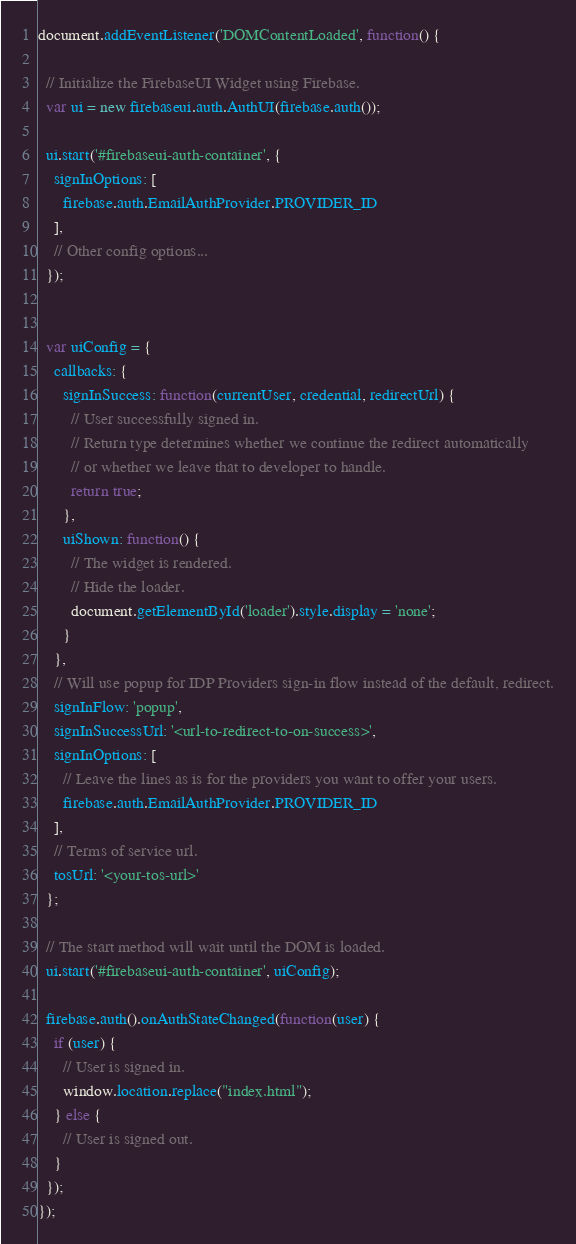Convert code to text. <code><loc_0><loc_0><loc_500><loc_500><_JavaScript_>document.addEventListener('DOMContentLoaded', function() {

  // Initialize the FirebaseUI Widget using Firebase.
  var ui = new firebaseui.auth.AuthUI(firebase.auth());

  ui.start('#firebaseui-auth-container', {
    signInOptions: [
      firebase.auth.EmailAuthProvider.PROVIDER_ID
    ],
    // Other config options...
  });


  var uiConfig = {
    callbacks: {
      signInSuccess: function(currentUser, credential, redirectUrl) {
        // User successfully signed in.
        // Return type determines whether we continue the redirect automatically
        // or whether we leave that to developer to handle.
        return true;
      },
      uiShown: function() {
        // The widget is rendered.
        // Hide the loader.
        document.getElementById('loader').style.display = 'none';
      }
    },
    // Will use popup for IDP Providers sign-in flow instead of the default, redirect.
    signInFlow: 'popup',
    signInSuccessUrl: '<url-to-redirect-to-on-success>',
    signInOptions: [
      // Leave the lines as is for the providers you want to offer your users.
      firebase.auth.EmailAuthProvider.PROVIDER_ID
    ],
    // Terms of service url.
    tosUrl: '<your-tos-url>'
  };

  // The start method will wait until the DOM is loaded.
  ui.start('#firebaseui-auth-container', uiConfig);

  firebase.auth().onAuthStateChanged(function(user) {
    if (user) {
      // User is signed in.
      window.location.replace("index.html");
    } else {
      // User is signed out.
    }
  });
});
</code> 